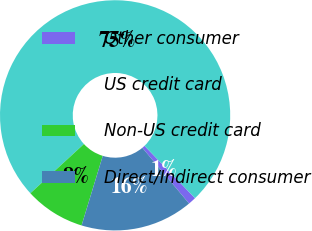Convert chart to OTSL. <chart><loc_0><loc_0><loc_500><loc_500><pie_chart><fcel>Other consumer<fcel>US credit card<fcel>Non-US credit card<fcel>Direct/Indirect consumer<nl><fcel>1.11%<fcel>74.61%<fcel>8.46%<fcel>15.81%<nl></chart> 